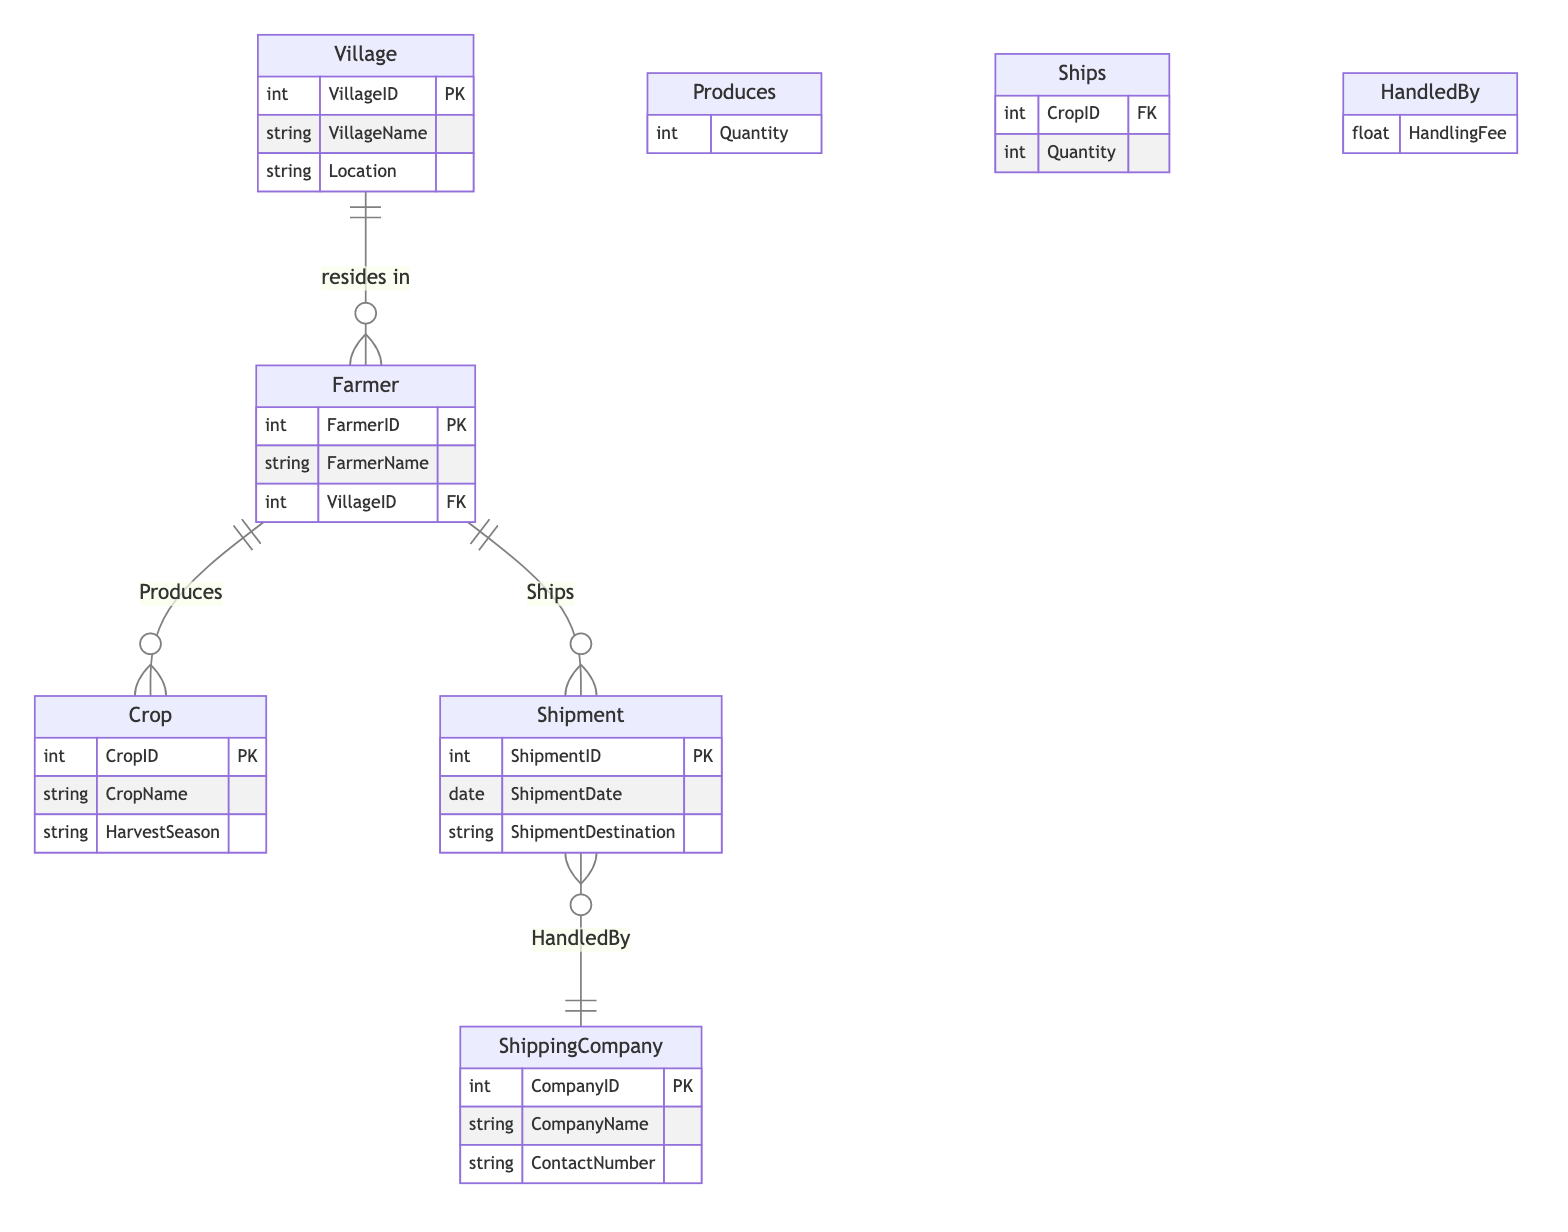What is the primary key of the Farmer entity? The primary key of the Farmer entity is indicated by PK, which represents the unique number identifying each farmer. From the diagram, it's specified as "FarmerID".
Answer: FarmerID How many attributes does the Shipment entity have? The Shipment entity contains four attributes listed in the diagram: ShipmentID, ShipmentDate, ShipmentDestination, and the relationship attribute from the HandledBy relationship. Counting these gives a total of three main attributes.
Answer: Three What type of relationship exists between Farmer and Crop? The line connecting Farmer and Crop in the diagram shows a one-to-many relationship, indicated by "Produces". This means one farmer can produce multiple crops.
Answer: One-to-many What fee is charged for handling each shipment? The handling fee for each shipment correlates with the relationship shown between Shipment and ShippingCompany, labeled as "HandlingFee". However, the specific value is not specified in the diagram itself.
Answer: HandlingFee Which entity does the Shipment have a many-to-one relationship with? The diagram shows a line connecting Shipment to ShippingCompany with a "HandledBy" relationship. This indicates that many shipments can be handled by one shipping company.
Answer: ShippingCompany Can a single farmer ship multiple types of crops? The diagram depicts that a farmer entity has a many-to-one relationship with shipments, meaning one farmer can be associated with several shipments for different crops. Thus, the answer is yes.
Answer: Yes What attribute links the Farmer entity to the Village entity? The link between the Farmer and Village entities is through the VillageID, where each Farmer resides in a specific Village, indicated by the foreign key relationship.
Answer: VillageID What is the quantity attribute associated with in the Ships relationship? In the Ships relationship, the Quantity attribute represents how much of a particular crop each shipment consists of, which links the Farmer to the Shipment.
Answer: Shipment How many entities are present in the diagram? The diagram lists five entities: Village, Farmer, Crop, Shipment, and ShippingCompany. Adding these entities together gives a total count of five.
Answer: Five 